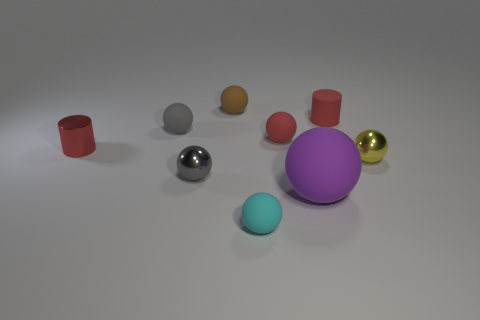How many things are either gray shiny spheres or tiny shiny cylinders? In the image, there are three objects that can be categorized as either gray shiny spheres or tiny shiny cylinders. Specifically, there is one large gray shiny sphere and two small shiny cylinders, one in red and one in purple. 